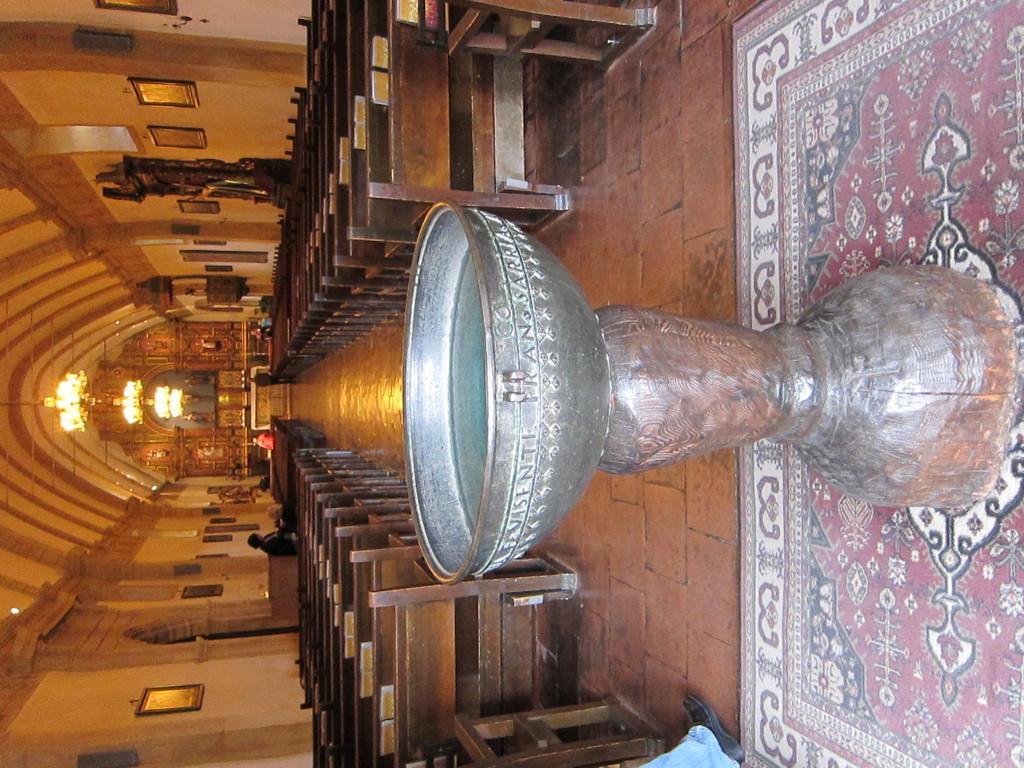Can you describe this image briefly? In this image we can see a silver object and we can also see benches, photo frames, arches, chandeliers and some other objects. 